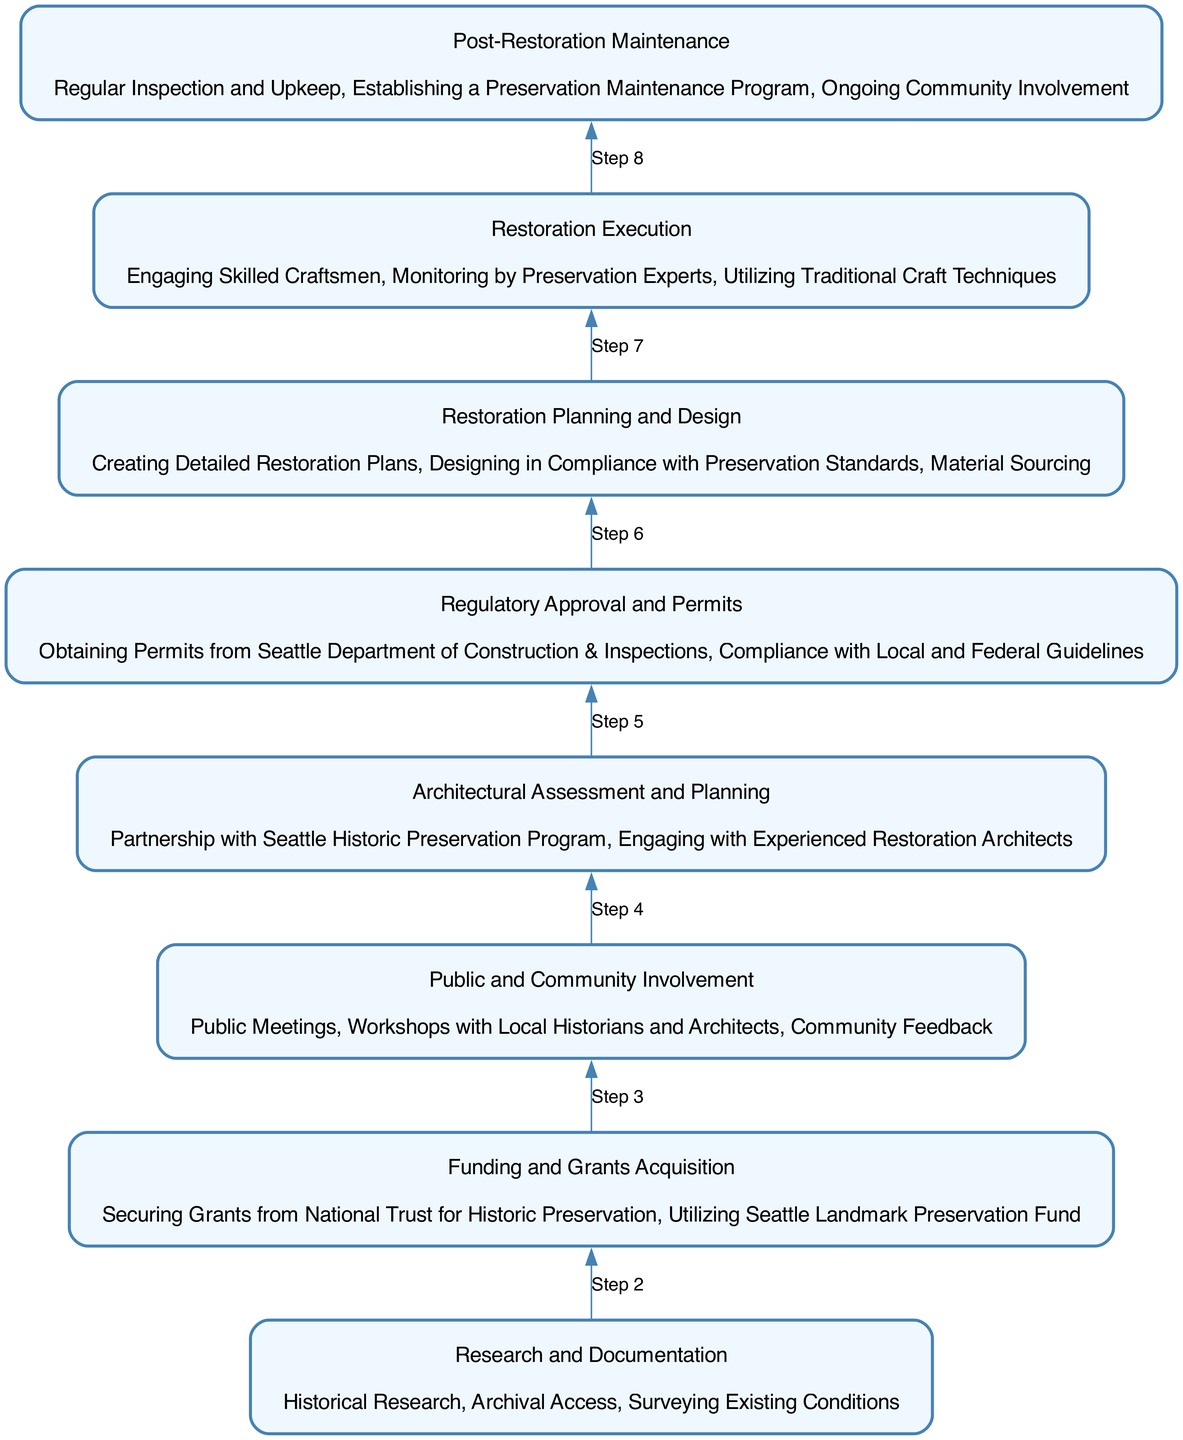What is the first step in the preservation and restoration process? The first step listed in the diagram is "Research and Documentation", as it is located at the bottom of the flow chart which indicates the starting point of the process.
Answer: Research and Documentation How many steps are there in total? By counting the steps represented in the diagram, there are a total of eight distinct steps outlined in the preservation and restoration process.
Answer: Eight What follows "Funding and Grants Acquisition"? The diagram shows that the step immediately following "Funding and Grants Acquisition" is "Public and Community Involvement", indicating the sequential flow of the process.
Answer: Public and Community Involvement Which step requires engaging with experienced restoration architects? This requirement is found in the "Architectural Assessment and Planning" step, which highlights the need to work with experts in restoration architecture during this phase.
Answer: Architectural Assessment and Planning Is "Post-Restoration Maintenance" towards the top or bottom of the diagram? "Post-Restoration Maintenance" is located towards the top of the diagram as it is one of the later steps in the process, indicating it occurs after all previous steps have been completed.
Answer: Top What is the primary goal of the step "Restoration Execution"? The primary goal of the "Restoration Execution" step is to carry out the actual restoration work, which includes engaging skilled craftsmen and utilizing traditional craft techniques as mentioned in the diagram.
Answer: Carry out the actual restoration work What permittance step is required before restoration can begin? The step that deals with obtaining necessary permissions before starting restoration is "Regulatory Approval and Permits", which comes after planning stages and ensures compliance before execution.
Answer: Regulatory Approval and Permits How is community input involved in the process? Community input is involved during the "Public and Community Involvement" step, which includes activities like public meetings and workshops to gather feedback.
Answer: Public and Community Involvement 